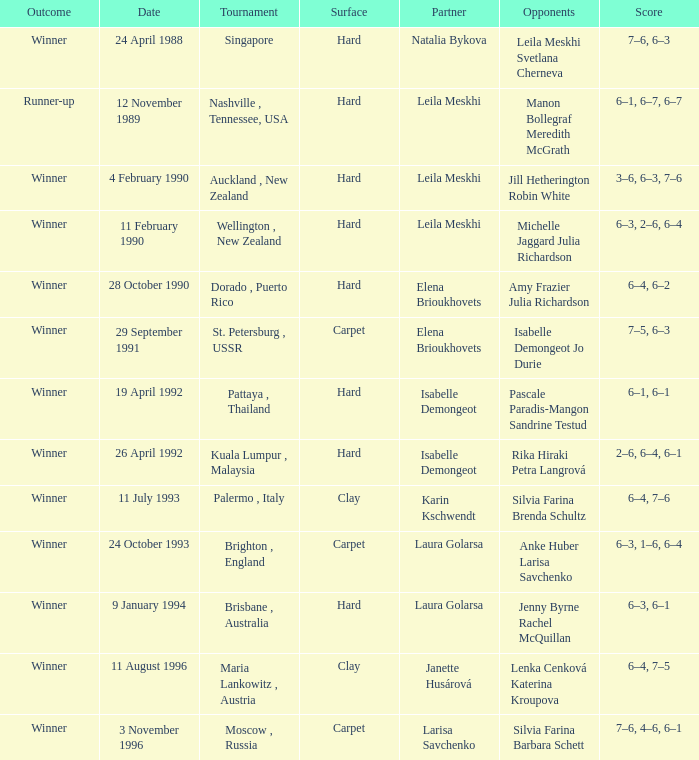During which tournament did a hard court match end with scores of 3-6, 6-3, and 7-6? Auckland , New Zealand. 